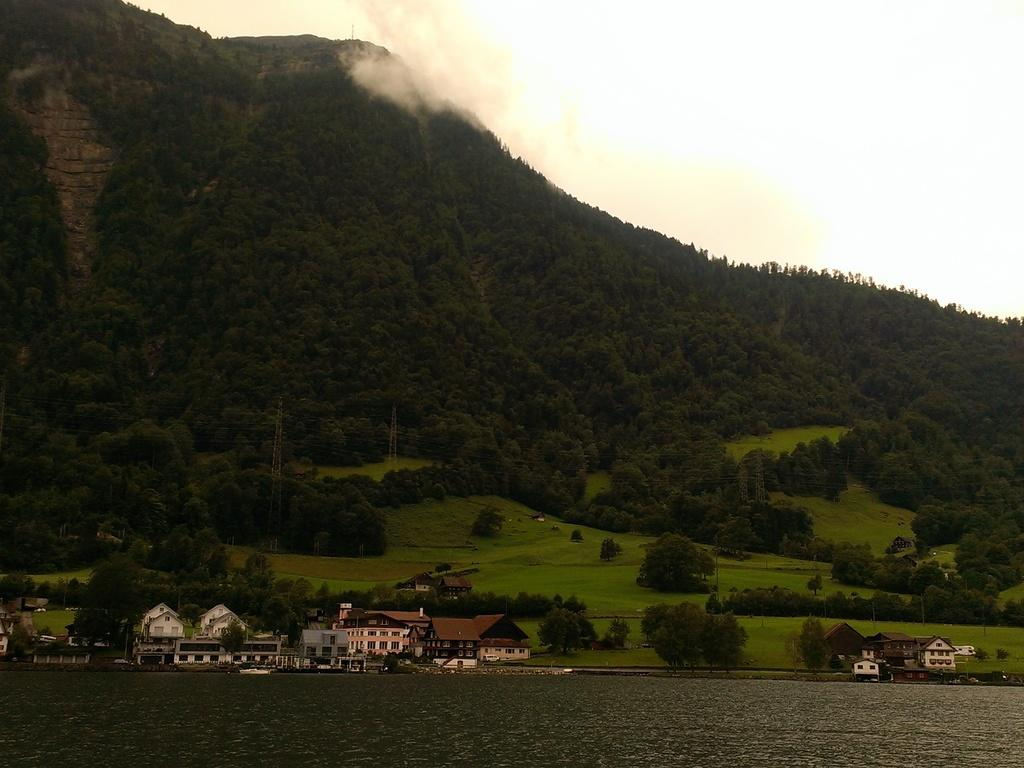What type of structures can be seen in the image? There is a group of buildings in the image. What natural elements are present in the image? There are trees and a mountain in the image. What man-made objects can be seen in the image? There are poles in the image. What type of landscape feature is visible in the image? There is water visible in the image. What can be seen in the background of the image? The sky is visible in the background of the image. Can you tell me how many appliances are visible in the image? There are no appliances present in the image. What type of hydrant is located near the water in the image? There is no hydrant present in the image. 